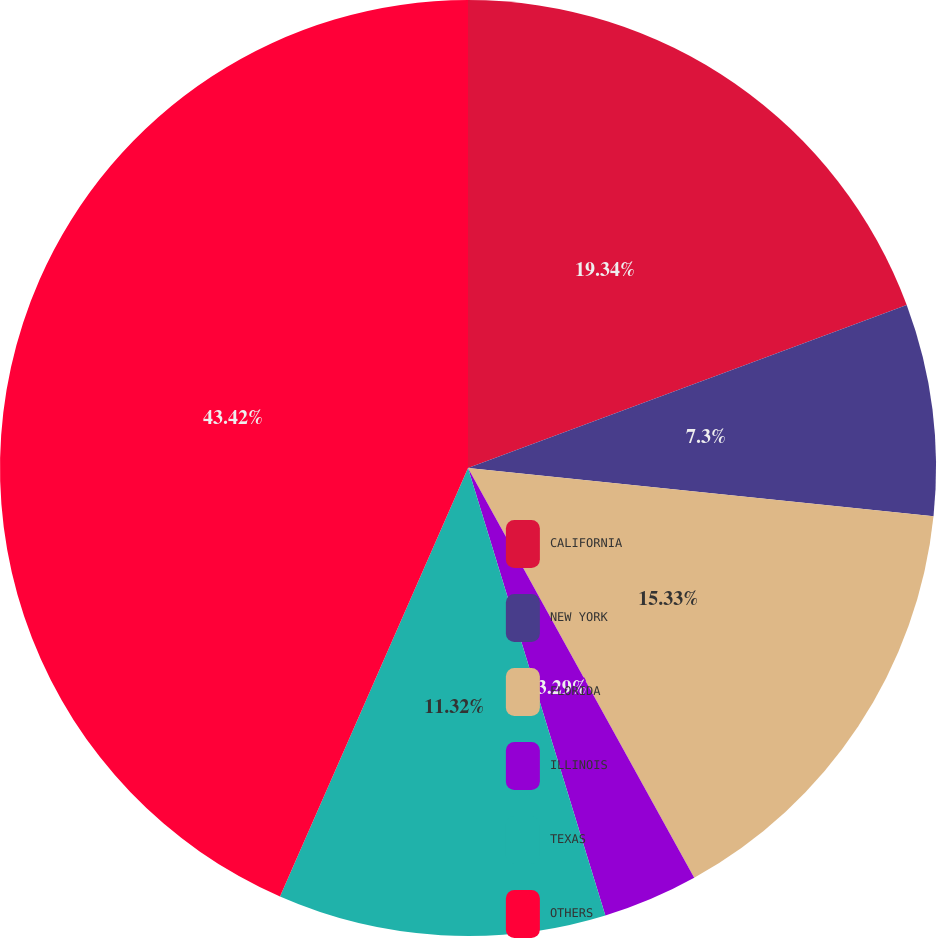Convert chart to OTSL. <chart><loc_0><loc_0><loc_500><loc_500><pie_chart><fcel>CALIFORNIA<fcel>NEW YORK<fcel>FLORIDA<fcel>ILLINOIS<fcel>TEXAS<fcel>OTHERS<nl><fcel>19.34%<fcel>7.3%<fcel>15.33%<fcel>3.29%<fcel>11.32%<fcel>43.42%<nl></chart> 